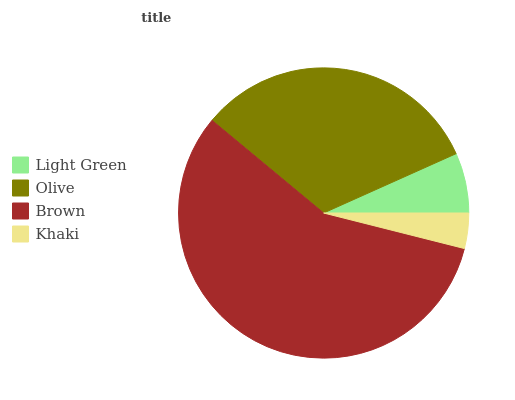Is Khaki the minimum?
Answer yes or no. Yes. Is Brown the maximum?
Answer yes or no. Yes. Is Olive the minimum?
Answer yes or no. No. Is Olive the maximum?
Answer yes or no. No. Is Olive greater than Light Green?
Answer yes or no. Yes. Is Light Green less than Olive?
Answer yes or no. Yes. Is Light Green greater than Olive?
Answer yes or no. No. Is Olive less than Light Green?
Answer yes or no. No. Is Olive the high median?
Answer yes or no. Yes. Is Light Green the low median?
Answer yes or no. Yes. Is Khaki the high median?
Answer yes or no. No. Is Brown the low median?
Answer yes or no. No. 